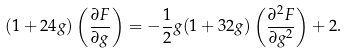Convert formula to latex. <formula><loc_0><loc_0><loc_500><loc_500>( 1 + 2 4 g ) \left ( \frac { \partial F } { \partial g } \right ) = - \frac { 1 } { 2 } g ( 1 + 3 2 g ) \left ( \frac { \partial ^ { 2 } F } { \partial g ^ { 2 } } \right ) + 2 .</formula> 